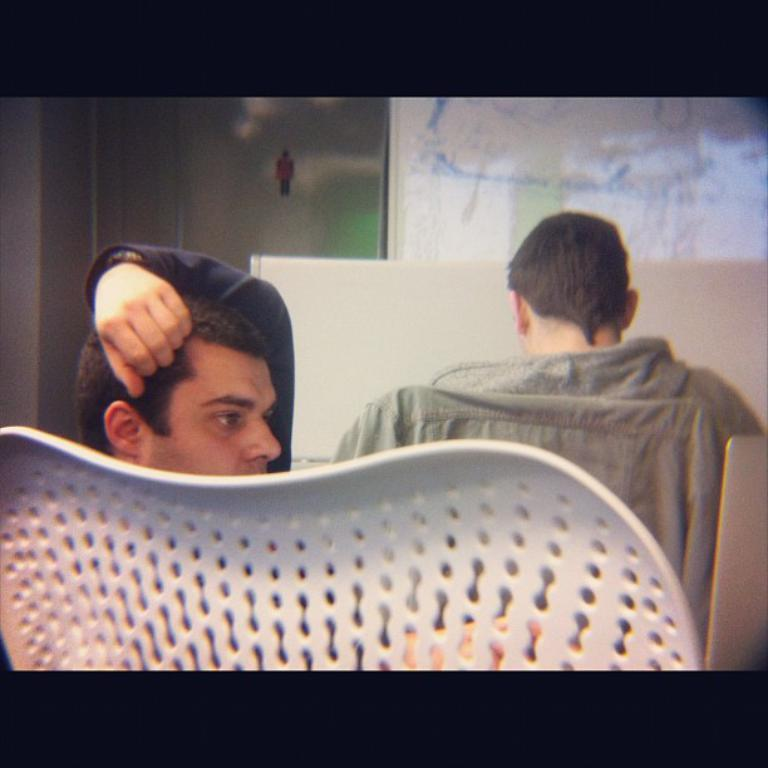How many people are in the image? There are two people in the image. What are the people doing in the image? The people are sitting on chairs. What can be observed about the people's clothing? The people are wearing different color dresses. What can be seen in the background of the image? There is a board visible in the background of the image. What is the profit margin of the plot of land in the image? There is no mention of a plot of land or profit margin in the image. 